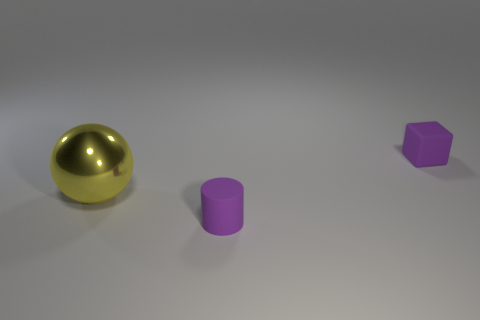Are there any other things that are the same size as the yellow metallic sphere?
Keep it short and to the point. No. Are there any other things that have the same material as the large yellow thing?
Make the answer very short. No. Are there any spheres that have the same size as the purple matte block?
Your response must be concise. No. There is a object that is the same material as the tiny purple cylinder; what is its color?
Provide a succinct answer. Purple. How many small rubber cylinders are to the right of the small purple thing that is in front of the big metallic thing?
Keep it short and to the point. 0. What material is the object that is behind the tiny purple rubber cylinder and right of the big sphere?
Provide a succinct answer. Rubber. Is the shape of the tiny purple rubber thing behind the big thing the same as  the yellow object?
Ensure brevity in your answer.  No. Are there fewer blue cylinders than large balls?
Offer a very short reply. Yes. How many tiny things have the same color as the metallic sphere?
Provide a succinct answer. 0. There is a small thing that is the same color as the small cube; what is it made of?
Provide a succinct answer. Rubber. 